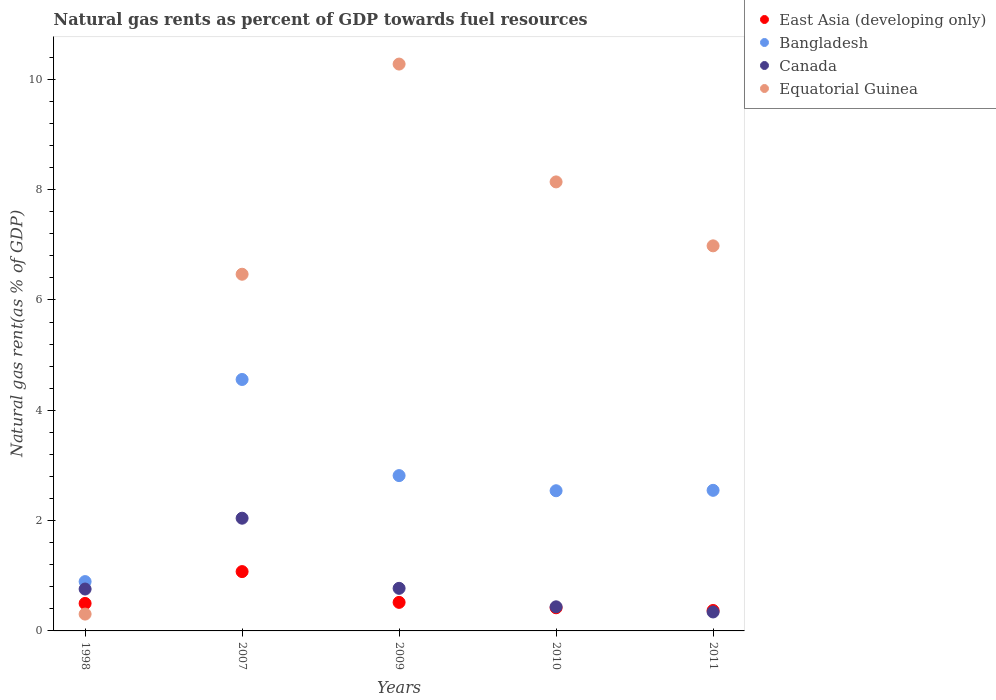How many different coloured dotlines are there?
Your response must be concise. 4. What is the natural gas rent in East Asia (developing only) in 2007?
Provide a succinct answer. 1.08. Across all years, what is the maximum natural gas rent in East Asia (developing only)?
Provide a succinct answer. 1.08. Across all years, what is the minimum natural gas rent in East Asia (developing only)?
Offer a terse response. 0.37. In which year was the natural gas rent in Bangladesh minimum?
Your answer should be very brief. 1998. What is the total natural gas rent in Canada in the graph?
Your answer should be compact. 4.36. What is the difference between the natural gas rent in Canada in 2007 and that in 2010?
Your response must be concise. 1.61. What is the difference between the natural gas rent in East Asia (developing only) in 1998 and the natural gas rent in Bangladesh in 2010?
Offer a very short reply. -2.04. What is the average natural gas rent in Equatorial Guinea per year?
Your answer should be compact. 6.43. In the year 1998, what is the difference between the natural gas rent in Canada and natural gas rent in East Asia (developing only)?
Give a very brief answer. 0.26. In how many years, is the natural gas rent in East Asia (developing only) greater than 0.4 %?
Provide a succinct answer. 4. What is the ratio of the natural gas rent in East Asia (developing only) in 1998 to that in 2009?
Your answer should be very brief. 0.96. Is the natural gas rent in Canada in 2009 less than that in 2010?
Your answer should be very brief. No. What is the difference between the highest and the second highest natural gas rent in East Asia (developing only)?
Offer a very short reply. 0.56. What is the difference between the highest and the lowest natural gas rent in Bangladesh?
Your answer should be compact. 3.66. Does the natural gas rent in Canada monotonically increase over the years?
Your response must be concise. No. Is the natural gas rent in Canada strictly less than the natural gas rent in East Asia (developing only) over the years?
Your answer should be compact. No. How many dotlines are there?
Your answer should be very brief. 4. How many years are there in the graph?
Offer a very short reply. 5. Where does the legend appear in the graph?
Your answer should be compact. Top right. How are the legend labels stacked?
Provide a short and direct response. Vertical. What is the title of the graph?
Ensure brevity in your answer.  Natural gas rents as percent of GDP towards fuel resources. Does "Romania" appear as one of the legend labels in the graph?
Your answer should be compact. No. What is the label or title of the X-axis?
Your answer should be very brief. Years. What is the label or title of the Y-axis?
Ensure brevity in your answer.  Natural gas rent(as % of GDP). What is the Natural gas rent(as % of GDP) in East Asia (developing only) in 1998?
Make the answer very short. 0.5. What is the Natural gas rent(as % of GDP) in Bangladesh in 1998?
Your answer should be very brief. 0.89. What is the Natural gas rent(as % of GDP) of Canada in 1998?
Provide a succinct answer. 0.76. What is the Natural gas rent(as % of GDP) of Equatorial Guinea in 1998?
Your response must be concise. 0.31. What is the Natural gas rent(as % of GDP) of East Asia (developing only) in 2007?
Give a very brief answer. 1.08. What is the Natural gas rent(as % of GDP) of Bangladesh in 2007?
Offer a terse response. 4.56. What is the Natural gas rent(as % of GDP) in Canada in 2007?
Your response must be concise. 2.04. What is the Natural gas rent(as % of GDP) in Equatorial Guinea in 2007?
Offer a terse response. 6.47. What is the Natural gas rent(as % of GDP) in East Asia (developing only) in 2009?
Offer a very short reply. 0.52. What is the Natural gas rent(as % of GDP) in Bangladesh in 2009?
Provide a short and direct response. 2.82. What is the Natural gas rent(as % of GDP) in Canada in 2009?
Offer a terse response. 0.77. What is the Natural gas rent(as % of GDP) of Equatorial Guinea in 2009?
Your answer should be compact. 10.28. What is the Natural gas rent(as % of GDP) in East Asia (developing only) in 2010?
Keep it short and to the point. 0.42. What is the Natural gas rent(as % of GDP) of Bangladesh in 2010?
Your response must be concise. 2.54. What is the Natural gas rent(as % of GDP) in Canada in 2010?
Your answer should be very brief. 0.44. What is the Natural gas rent(as % of GDP) of Equatorial Guinea in 2010?
Make the answer very short. 8.14. What is the Natural gas rent(as % of GDP) in East Asia (developing only) in 2011?
Make the answer very short. 0.37. What is the Natural gas rent(as % of GDP) of Bangladesh in 2011?
Your response must be concise. 2.55. What is the Natural gas rent(as % of GDP) of Canada in 2011?
Give a very brief answer. 0.34. What is the Natural gas rent(as % of GDP) of Equatorial Guinea in 2011?
Provide a short and direct response. 6.98. Across all years, what is the maximum Natural gas rent(as % of GDP) of East Asia (developing only)?
Give a very brief answer. 1.08. Across all years, what is the maximum Natural gas rent(as % of GDP) of Bangladesh?
Provide a short and direct response. 4.56. Across all years, what is the maximum Natural gas rent(as % of GDP) in Canada?
Ensure brevity in your answer.  2.04. Across all years, what is the maximum Natural gas rent(as % of GDP) in Equatorial Guinea?
Provide a short and direct response. 10.28. Across all years, what is the minimum Natural gas rent(as % of GDP) in East Asia (developing only)?
Provide a succinct answer. 0.37. Across all years, what is the minimum Natural gas rent(as % of GDP) in Bangladesh?
Keep it short and to the point. 0.89. Across all years, what is the minimum Natural gas rent(as % of GDP) in Canada?
Offer a terse response. 0.34. Across all years, what is the minimum Natural gas rent(as % of GDP) of Equatorial Guinea?
Your answer should be very brief. 0.31. What is the total Natural gas rent(as % of GDP) of East Asia (developing only) in the graph?
Give a very brief answer. 2.88. What is the total Natural gas rent(as % of GDP) in Bangladesh in the graph?
Offer a very short reply. 13.36. What is the total Natural gas rent(as % of GDP) in Canada in the graph?
Your answer should be compact. 4.36. What is the total Natural gas rent(as % of GDP) in Equatorial Guinea in the graph?
Provide a succinct answer. 32.17. What is the difference between the Natural gas rent(as % of GDP) in East Asia (developing only) in 1998 and that in 2007?
Ensure brevity in your answer.  -0.58. What is the difference between the Natural gas rent(as % of GDP) in Bangladesh in 1998 and that in 2007?
Your answer should be very brief. -3.66. What is the difference between the Natural gas rent(as % of GDP) of Canada in 1998 and that in 2007?
Provide a short and direct response. -1.28. What is the difference between the Natural gas rent(as % of GDP) of Equatorial Guinea in 1998 and that in 2007?
Provide a succinct answer. -6.16. What is the difference between the Natural gas rent(as % of GDP) of East Asia (developing only) in 1998 and that in 2009?
Make the answer very short. -0.02. What is the difference between the Natural gas rent(as % of GDP) in Bangladesh in 1998 and that in 2009?
Your answer should be compact. -1.92. What is the difference between the Natural gas rent(as % of GDP) in Canada in 1998 and that in 2009?
Provide a short and direct response. -0.01. What is the difference between the Natural gas rent(as % of GDP) in Equatorial Guinea in 1998 and that in 2009?
Offer a very short reply. -9.97. What is the difference between the Natural gas rent(as % of GDP) of East Asia (developing only) in 1998 and that in 2010?
Your answer should be compact. 0.08. What is the difference between the Natural gas rent(as % of GDP) in Bangladesh in 1998 and that in 2010?
Your response must be concise. -1.65. What is the difference between the Natural gas rent(as % of GDP) in Canada in 1998 and that in 2010?
Your answer should be compact. 0.32. What is the difference between the Natural gas rent(as % of GDP) in Equatorial Guinea in 1998 and that in 2010?
Your answer should be very brief. -7.84. What is the difference between the Natural gas rent(as % of GDP) in East Asia (developing only) in 1998 and that in 2011?
Offer a very short reply. 0.13. What is the difference between the Natural gas rent(as % of GDP) of Bangladesh in 1998 and that in 2011?
Your response must be concise. -1.65. What is the difference between the Natural gas rent(as % of GDP) of Canada in 1998 and that in 2011?
Give a very brief answer. 0.42. What is the difference between the Natural gas rent(as % of GDP) of Equatorial Guinea in 1998 and that in 2011?
Keep it short and to the point. -6.68. What is the difference between the Natural gas rent(as % of GDP) of East Asia (developing only) in 2007 and that in 2009?
Keep it short and to the point. 0.56. What is the difference between the Natural gas rent(as % of GDP) of Bangladesh in 2007 and that in 2009?
Provide a succinct answer. 1.74. What is the difference between the Natural gas rent(as % of GDP) in Canada in 2007 and that in 2009?
Make the answer very short. 1.27. What is the difference between the Natural gas rent(as % of GDP) of Equatorial Guinea in 2007 and that in 2009?
Provide a succinct answer. -3.81. What is the difference between the Natural gas rent(as % of GDP) in East Asia (developing only) in 2007 and that in 2010?
Offer a very short reply. 0.66. What is the difference between the Natural gas rent(as % of GDP) in Bangladesh in 2007 and that in 2010?
Your response must be concise. 2.02. What is the difference between the Natural gas rent(as % of GDP) of Canada in 2007 and that in 2010?
Provide a succinct answer. 1.61. What is the difference between the Natural gas rent(as % of GDP) of Equatorial Guinea in 2007 and that in 2010?
Provide a short and direct response. -1.67. What is the difference between the Natural gas rent(as % of GDP) of East Asia (developing only) in 2007 and that in 2011?
Make the answer very short. 0.71. What is the difference between the Natural gas rent(as % of GDP) of Bangladesh in 2007 and that in 2011?
Offer a terse response. 2.01. What is the difference between the Natural gas rent(as % of GDP) of Canada in 2007 and that in 2011?
Your answer should be very brief. 1.7. What is the difference between the Natural gas rent(as % of GDP) of Equatorial Guinea in 2007 and that in 2011?
Keep it short and to the point. -0.51. What is the difference between the Natural gas rent(as % of GDP) in East Asia (developing only) in 2009 and that in 2010?
Offer a very short reply. 0.1. What is the difference between the Natural gas rent(as % of GDP) in Bangladesh in 2009 and that in 2010?
Make the answer very short. 0.27. What is the difference between the Natural gas rent(as % of GDP) in Canada in 2009 and that in 2010?
Give a very brief answer. 0.34. What is the difference between the Natural gas rent(as % of GDP) of Equatorial Guinea in 2009 and that in 2010?
Make the answer very short. 2.14. What is the difference between the Natural gas rent(as % of GDP) of East Asia (developing only) in 2009 and that in 2011?
Keep it short and to the point. 0.15. What is the difference between the Natural gas rent(as % of GDP) of Bangladesh in 2009 and that in 2011?
Provide a short and direct response. 0.27. What is the difference between the Natural gas rent(as % of GDP) in Canada in 2009 and that in 2011?
Offer a terse response. 0.43. What is the difference between the Natural gas rent(as % of GDP) in Equatorial Guinea in 2009 and that in 2011?
Offer a very short reply. 3.3. What is the difference between the Natural gas rent(as % of GDP) of East Asia (developing only) in 2010 and that in 2011?
Your answer should be very brief. 0.05. What is the difference between the Natural gas rent(as % of GDP) in Bangladesh in 2010 and that in 2011?
Ensure brevity in your answer.  -0.01. What is the difference between the Natural gas rent(as % of GDP) in Canada in 2010 and that in 2011?
Your answer should be compact. 0.09. What is the difference between the Natural gas rent(as % of GDP) of Equatorial Guinea in 2010 and that in 2011?
Your answer should be very brief. 1.16. What is the difference between the Natural gas rent(as % of GDP) of East Asia (developing only) in 1998 and the Natural gas rent(as % of GDP) of Bangladesh in 2007?
Offer a very short reply. -4.06. What is the difference between the Natural gas rent(as % of GDP) in East Asia (developing only) in 1998 and the Natural gas rent(as % of GDP) in Canada in 2007?
Give a very brief answer. -1.54. What is the difference between the Natural gas rent(as % of GDP) in East Asia (developing only) in 1998 and the Natural gas rent(as % of GDP) in Equatorial Guinea in 2007?
Offer a terse response. -5.97. What is the difference between the Natural gas rent(as % of GDP) in Bangladesh in 1998 and the Natural gas rent(as % of GDP) in Canada in 2007?
Your answer should be very brief. -1.15. What is the difference between the Natural gas rent(as % of GDP) in Bangladesh in 1998 and the Natural gas rent(as % of GDP) in Equatorial Guinea in 2007?
Offer a terse response. -5.57. What is the difference between the Natural gas rent(as % of GDP) in Canada in 1998 and the Natural gas rent(as % of GDP) in Equatorial Guinea in 2007?
Provide a short and direct response. -5.71. What is the difference between the Natural gas rent(as % of GDP) of East Asia (developing only) in 1998 and the Natural gas rent(as % of GDP) of Bangladesh in 2009?
Keep it short and to the point. -2.32. What is the difference between the Natural gas rent(as % of GDP) of East Asia (developing only) in 1998 and the Natural gas rent(as % of GDP) of Canada in 2009?
Make the answer very short. -0.27. What is the difference between the Natural gas rent(as % of GDP) of East Asia (developing only) in 1998 and the Natural gas rent(as % of GDP) of Equatorial Guinea in 2009?
Offer a terse response. -9.78. What is the difference between the Natural gas rent(as % of GDP) in Bangladesh in 1998 and the Natural gas rent(as % of GDP) in Canada in 2009?
Provide a short and direct response. 0.12. What is the difference between the Natural gas rent(as % of GDP) in Bangladesh in 1998 and the Natural gas rent(as % of GDP) in Equatorial Guinea in 2009?
Your response must be concise. -9.38. What is the difference between the Natural gas rent(as % of GDP) of Canada in 1998 and the Natural gas rent(as % of GDP) of Equatorial Guinea in 2009?
Offer a terse response. -9.52. What is the difference between the Natural gas rent(as % of GDP) of East Asia (developing only) in 1998 and the Natural gas rent(as % of GDP) of Bangladesh in 2010?
Provide a succinct answer. -2.04. What is the difference between the Natural gas rent(as % of GDP) in East Asia (developing only) in 1998 and the Natural gas rent(as % of GDP) in Canada in 2010?
Provide a succinct answer. 0.06. What is the difference between the Natural gas rent(as % of GDP) of East Asia (developing only) in 1998 and the Natural gas rent(as % of GDP) of Equatorial Guinea in 2010?
Ensure brevity in your answer.  -7.64. What is the difference between the Natural gas rent(as % of GDP) of Bangladesh in 1998 and the Natural gas rent(as % of GDP) of Canada in 2010?
Provide a succinct answer. 0.46. What is the difference between the Natural gas rent(as % of GDP) in Bangladesh in 1998 and the Natural gas rent(as % of GDP) in Equatorial Guinea in 2010?
Keep it short and to the point. -7.25. What is the difference between the Natural gas rent(as % of GDP) of Canada in 1998 and the Natural gas rent(as % of GDP) of Equatorial Guinea in 2010?
Your answer should be very brief. -7.38. What is the difference between the Natural gas rent(as % of GDP) of East Asia (developing only) in 1998 and the Natural gas rent(as % of GDP) of Bangladesh in 2011?
Make the answer very short. -2.05. What is the difference between the Natural gas rent(as % of GDP) in East Asia (developing only) in 1998 and the Natural gas rent(as % of GDP) in Canada in 2011?
Keep it short and to the point. 0.15. What is the difference between the Natural gas rent(as % of GDP) in East Asia (developing only) in 1998 and the Natural gas rent(as % of GDP) in Equatorial Guinea in 2011?
Provide a short and direct response. -6.48. What is the difference between the Natural gas rent(as % of GDP) of Bangladesh in 1998 and the Natural gas rent(as % of GDP) of Canada in 2011?
Your answer should be very brief. 0.55. What is the difference between the Natural gas rent(as % of GDP) of Bangladesh in 1998 and the Natural gas rent(as % of GDP) of Equatorial Guinea in 2011?
Provide a short and direct response. -6.09. What is the difference between the Natural gas rent(as % of GDP) of Canada in 1998 and the Natural gas rent(as % of GDP) of Equatorial Guinea in 2011?
Your answer should be very brief. -6.22. What is the difference between the Natural gas rent(as % of GDP) of East Asia (developing only) in 2007 and the Natural gas rent(as % of GDP) of Bangladesh in 2009?
Your answer should be very brief. -1.74. What is the difference between the Natural gas rent(as % of GDP) in East Asia (developing only) in 2007 and the Natural gas rent(as % of GDP) in Canada in 2009?
Your answer should be compact. 0.3. What is the difference between the Natural gas rent(as % of GDP) of East Asia (developing only) in 2007 and the Natural gas rent(as % of GDP) of Equatorial Guinea in 2009?
Make the answer very short. -9.2. What is the difference between the Natural gas rent(as % of GDP) in Bangladesh in 2007 and the Natural gas rent(as % of GDP) in Canada in 2009?
Offer a terse response. 3.79. What is the difference between the Natural gas rent(as % of GDP) in Bangladesh in 2007 and the Natural gas rent(as % of GDP) in Equatorial Guinea in 2009?
Provide a succinct answer. -5.72. What is the difference between the Natural gas rent(as % of GDP) of Canada in 2007 and the Natural gas rent(as % of GDP) of Equatorial Guinea in 2009?
Offer a terse response. -8.23. What is the difference between the Natural gas rent(as % of GDP) of East Asia (developing only) in 2007 and the Natural gas rent(as % of GDP) of Bangladesh in 2010?
Your answer should be very brief. -1.47. What is the difference between the Natural gas rent(as % of GDP) in East Asia (developing only) in 2007 and the Natural gas rent(as % of GDP) in Canada in 2010?
Your answer should be very brief. 0.64. What is the difference between the Natural gas rent(as % of GDP) of East Asia (developing only) in 2007 and the Natural gas rent(as % of GDP) of Equatorial Guinea in 2010?
Provide a short and direct response. -7.07. What is the difference between the Natural gas rent(as % of GDP) of Bangladesh in 2007 and the Natural gas rent(as % of GDP) of Canada in 2010?
Provide a short and direct response. 4.12. What is the difference between the Natural gas rent(as % of GDP) of Bangladesh in 2007 and the Natural gas rent(as % of GDP) of Equatorial Guinea in 2010?
Your response must be concise. -3.58. What is the difference between the Natural gas rent(as % of GDP) of Canada in 2007 and the Natural gas rent(as % of GDP) of Equatorial Guinea in 2010?
Your answer should be compact. -6.1. What is the difference between the Natural gas rent(as % of GDP) in East Asia (developing only) in 2007 and the Natural gas rent(as % of GDP) in Bangladesh in 2011?
Provide a succinct answer. -1.47. What is the difference between the Natural gas rent(as % of GDP) in East Asia (developing only) in 2007 and the Natural gas rent(as % of GDP) in Canada in 2011?
Make the answer very short. 0.73. What is the difference between the Natural gas rent(as % of GDP) in East Asia (developing only) in 2007 and the Natural gas rent(as % of GDP) in Equatorial Guinea in 2011?
Offer a terse response. -5.91. What is the difference between the Natural gas rent(as % of GDP) in Bangladesh in 2007 and the Natural gas rent(as % of GDP) in Canada in 2011?
Your answer should be compact. 4.21. What is the difference between the Natural gas rent(as % of GDP) of Bangladesh in 2007 and the Natural gas rent(as % of GDP) of Equatorial Guinea in 2011?
Ensure brevity in your answer.  -2.42. What is the difference between the Natural gas rent(as % of GDP) of Canada in 2007 and the Natural gas rent(as % of GDP) of Equatorial Guinea in 2011?
Keep it short and to the point. -4.94. What is the difference between the Natural gas rent(as % of GDP) of East Asia (developing only) in 2009 and the Natural gas rent(as % of GDP) of Bangladesh in 2010?
Make the answer very short. -2.02. What is the difference between the Natural gas rent(as % of GDP) in East Asia (developing only) in 2009 and the Natural gas rent(as % of GDP) in Canada in 2010?
Make the answer very short. 0.08. What is the difference between the Natural gas rent(as % of GDP) in East Asia (developing only) in 2009 and the Natural gas rent(as % of GDP) in Equatorial Guinea in 2010?
Your response must be concise. -7.62. What is the difference between the Natural gas rent(as % of GDP) in Bangladesh in 2009 and the Natural gas rent(as % of GDP) in Canada in 2010?
Provide a succinct answer. 2.38. What is the difference between the Natural gas rent(as % of GDP) of Bangladesh in 2009 and the Natural gas rent(as % of GDP) of Equatorial Guinea in 2010?
Your response must be concise. -5.32. What is the difference between the Natural gas rent(as % of GDP) of Canada in 2009 and the Natural gas rent(as % of GDP) of Equatorial Guinea in 2010?
Your response must be concise. -7.37. What is the difference between the Natural gas rent(as % of GDP) in East Asia (developing only) in 2009 and the Natural gas rent(as % of GDP) in Bangladesh in 2011?
Give a very brief answer. -2.03. What is the difference between the Natural gas rent(as % of GDP) of East Asia (developing only) in 2009 and the Natural gas rent(as % of GDP) of Canada in 2011?
Offer a terse response. 0.17. What is the difference between the Natural gas rent(as % of GDP) in East Asia (developing only) in 2009 and the Natural gas rent(as % of GDP) in Equatorial Guinea in 2011?
Your answer should be compact. -6.46. What is the difference between the Natural gas rent(as % of GDP) of Bangladesh in 2009 and the Natural gas rent(as % of GDP) of Canada in 2011?
Your response must be concise. 2.47. What is the difference between the Natural gas rent(as % of GDP) of Bangladesh in 2009 and the Natural gas rent(as % of GDP) of Equatorial Guinea in 2011?
Your response must be concise. -4.17. What is the difference between the Natural gas rent(as % of GDP) of Canada in 2009 and the Natural gas rent(as % of GDP) of Equatorial Guinea in 2011?
Provide a short and direct response. -6.21. What is the difference between the Natural gas rent(as % of GDP) in East Asia (developing only) in 2010 and the Natural gas rent(as % of GDP) in Bangladesh in 2011?
Keep it short and to the point. -2.13. What is the difference between the Natural gas rent(as % of GDP) of East Asia (developing only) in 2010 and the Natural gas rent(as % of GDP) of Canada in 2011?
Ensure brevity in your answer.  0.08. What is the difference between the Natural gas rent(as % of GDP) of East Asia (developing only) in 2010 and the Natural gas rent(as % of GDP) of Equatorial Guinea in 2011?
Your answer should be very brief. -6.56. What is the difference between the Natural gas rent(as % of GDP) in Bangladesh in 2010 and the Natural gas rent(as % of GDP) in Canada in 2011?
Your response must be concise. 2.2. What is the difference between the Natural gas rent(as % of GDP) in Bangladesh in 2010 and the Natural gas rent(as % of GDP) in Equatorial Guinea in 2011?
Your answer should be very brief. -4.44. What is the difference between the Natural gas rent(as % of GDP) in Canada in 2010 and the Natural gas rent(as % of GDP) in Equatorial Guinea in 2011?
Ensure brevity in your answer.  -6.54. What is the average Natural gas rent(as % of GDP) in East Asia (developing only) per year?
Offer a very short reply. 0.58. What is the average Natural gas rent(as % of GDP) of Bangladesh per year?
Offer a very short reply. 2.67. What is the average Natural gas rent(as % of GDP) in Canada per year?
Offer a terse response. 0.87. What is the average Natural gas rent(as % of GDP) in Equatorial Guinea per year?
Your answer should be very brief. 6.43. In the year 1998, what is the difference between the Natural gas rent(as % of GDP) in East Asia (developing only) and Natural gas rent(as % of GDP) in Bangladesh?
Your response must be concise. -0.4. In the year 1998, what is the difference between the Natural gas rent(as % of GDP) of East Asia (developing only) and Natural gas rent(as % of GDP) of Canada?
Provide a short and direct response. -0.26. In the year 1998, what is the difference between the Natural gas rent(as % of GDP) in East Asia (developing only) and Natural gas rent(as % of GDP) in Equatorial Guinea?
Keep it short and to the point. 0.19. In the year 1998, what is the difference between the Natural gas rent(as % of GDP) in Bangladesh and Natural gas rent(as % of GDP) in Canada?
Provide a succinct answer. 0.13. In the year 1998, what is the difference between the Natural gas rent(as % of GDP) in Bangladesh and Natural gas rent(as % of GDP) in Equatorial Guinea?
Offer a very short reply. 0.59. In the year 1998, what is the difference between the Natural gas rent(as % of GDP) of Canada and Natural gas rent(as % of GDP) of Equatorial Guinea?
Offer a very short reply. 0.45. In the year 2007, what is the difference between the Natural gas rent(as % of GDP) of East Asia (developing only) and Natural gas rent(as % of GDP) of Bangladesh?
Your answer should be compact. -3.48. In the year 2007, what is the difference between the Natural gas rent(as % of GDP) in East Asia (developing only) and Natural gas rent(as % of GDP) in Canada?
Offer a terse response. -0.97. In the year 2007, what is the difference between the Natural gas rent(as % of GDP) in East Asia (developing only) and Natural gas rent(as % of GDP) in Equatorial Guinea?
Make the answer very short. -5.39. In the year 2007, what is the difference between the Natural gas rent(as % of GDP) of Bangladesh and Natural gas rent(as % of GDP) of Canada?
Provide a short and direct response. 2.52. In the year 2007, what is the difference between the Natural gas rent(as % of GDP) in Bangladesh and Natural gas rent(as % of GDP) in Equatorial Guinea?
Offer a very short reply. -1.91. In the year 2007, what is the difference between the Natural gas rent(as % of GDP) in Canada and Natural gas rent(as % of GDP) in Equatorial Guinea?
Offer a terse response. -4.42. In the year 2009, what is the difference between the Natural gas rent(as % of GDP) of East Asia (developing only) and Natural gas rent(as % of GDP) of Bangladesh?
Offer a terse response. -2.3. In the year 2009, what is the difference between the Natural gas rent(as % of GDP) in East Asia (developing only) and Natural gas rent(as % of GDP) in Canada?
Provide a short and direct response. -0.25. In the year 2009, what is the difference between the Natural gas rent(as % of GDP) in East Asia (developing only) and Natural gas rent(as % of GDP) in Equatorial Guinea?
Your response must be concise. -9.76. In the year 2009, what is the difference between the Natural gas rent(as % of GDP) in Bangladesh and Natural gas rent(as % of GDP) in Canada?
Provide a succinct answer. 2.04. In the year 2009, what is the difference between the Natural gas rent(as % of GDP) in Bangladesh and Natural gas rent(as % of GDP) in Equatorial Guinea?
Your response must be concise. -7.46. In the year 2009, what is the difference between the Natural gas rent(as % of GDP) in Canada and Natural gas rent(as % of GDP) in Equatorial Guinea?
Offer a very short reply. -9.5. In the year 2010, what is the difference between the Natural gas rent(as % of GDP) in East Asia (developing only) and Natural gas rent(as % of GDP) in Bangladesh?
Keep it short and to the point. -2.12. In the year 2010, what is the difference between the Natural gas rent(as % of GDP) of East Asia (developing only) and Natural gas rent(as % of GDP) of Canada?
Offer a terse response. -0.02. In the year 2010, what is the difference between the Natural gas rent(as % of GDP) in East Asia (developing only) and Natural gas rent(as % of GDP) in Equatorial Guinea?
Offer a very short reply. -7.72. In the year 2010, what is the difference between the Natural gas rent(as % of GDP) in Bangladesh and Natural gas rent(as % of GDP) in Canada?
Make the answer very short. 2.1. In the year 2010, what is the difference between the Natural gas rent(as % of GDP) of Bangladesh and Natural gas rent(as % of GDP) of Equatorial Guinea?
Provide a succinct answer. -5.6. In the year 2010, what is the difference between the Natural gas rent(as % of GDP) of Canada and Natural gas rent(as % of GDP) of Equatorial Guinea?
Offer a terse response. -7.7. In the year 2011, what is the difference between the Natural gas rent(as % of GDP) in East Asia (developing only) and Natural gas rent(as % of GDP) in Bangladesh?
Give a very brief answer. -2.18. In the year 2011, what is the difference between the Natural gas rent(as % of GDP) of East Asia (developing only) and Natural gas rent(as % of GDP) of Canada?
Your answer should be compact. 0.03. In the year 2011, what is the difference between the Natural gas rent(as % of GDP) of East Asia (developing only) and Natural gas rent(as % of GDP) of Equatorial Guinea?
Provide a short and direct response. -6.61. In the year 2011, what is the difference between the Natural gas rent(as % of GDP) in Bangladesh and Natural gas rent(as % of GDP) in Canada?
Your answer should be compact. 2.21. In the year 2011, what is the difference between the Natural gas rent(as % of GDP) of Bangladesh and Natural gas rent(as % of GDP) of Equatorial Guinea?
Your answer should be compact. -4.43. In the year 2011, what is the difference between the Natural gas rent(as % of GDP) of Canada and Natural gas rent(as % of GDP) of Equatorial Guinea?
Keep it short and to the point. -6.64. What is the ratio of the Natural gas rent(as % of GDP) in East Asia (developing only) in 1998 to that in 2007?
Your answer should be compact. 0.46. What is the ratio of the Natural gas rent(as % of GDP) in Bangladesh in 1998 to that in 2007?
Make the answer very short. 0.2. What is the ratio of the Natural gas rent(as % of GDP) of Canada in 1998 to that in 2007?
Offer a very short reply. 0.37. What is the ratio of the Natural gas rent(as % of GDP) of Equatorial Guinea in 1998 to that in 2007?
Provide a succinct answer. 0.05. What is the ratio of the Natural gas rent(as % of GDP) of East Asia (developing only) in 1998 to that in 2009?
Your answer should be compact. 0.96. What is the ratio of the Natural gas rent(as % of GDP) in Bangladesh in 1998 to that in 2009?
Give a very brief answer. 0.32. What is the ratio of the Natural gas rent(as % of GDP) of Canada in 1998 to that in 2009?
Provide a short and direct response. 0.98. What is the ratio of the Natural gas rent(as % of GDP) of Equatorial Guinea in 1998 to that in 2009?
Give a very brief answer. 0.03. What is the ratio of the Natural gas rent(as % of GDP) in East Asia (developing only) in 1998 to that in 2010?
Provide a short and direct response. 1.19. What is the ratio of the Natural gas rent(as % of GDP) of Bangladesh in 1998 to that in 2010?
Offer a very short reply. 0.35. What is the ratio of the Natural gas rent(as % of GDP) in Canada in 1998 to that in 2010?
Your answer should be compact. 1.74. What is the ratio of the Natural gas rent(as % of GDP) in Equatorial Guinea in 1998 to that in 2010?
Provide a succinct answer. 0.04. What is the ratio of the Natural gas rent(as % of GDP) of East Asia (developing only) in 1998 to that in 2011?
Your answer should be very brief. 1.35. What is the ratio of the Natural gas rent(as % of GDP) in Bangladesh in 1998 to that in 2011?
Offer a very short reply. 0.35. What is the ratio of the Natural gas rent(as % of GDP) in Canada in 1998 to that in 2011?
Make the answer very short. 2.21. What is the ratio of the Natural gas rent(as % of GDP) of Equatorial Guinea in 1998 to that in 2011?
Ensure brevity in your answer.  0.04. What is the ratio of the Natural gas rent(as % of GDP) in East Asia (developing only) in 2007 to that in 2009?
Provide a succinct answer. 2.08. What is the ratio of the Natural gas rent(as % of GDP) in Bangladesh in 2007 to that in 2009?
Your answer should be very brief. 1.62. What is the ratio of the Natural gas rent(as % of GDP) of Canada in 2007 to that in 2009?
Offer a very short reply. 2.65. What is the ratio of the Natural gas rent(as % of GDP) in Equatorial Guinea in 2007 to that in 2009?
Your response must be concise. 0.63. What is the ratio of the Natural gas rent(as % of GDP) of East Asia (developing only) in 2007 to that in 2010?
Provide a short and direct response. 2.56. What is the ratio of the Natural gas rent(as % of GDP) in Bangladesh in 2007 to that in 2010?
Provide a succinct answer. 1.79. What is the ratio of the Natural gas rent(as % of GDP) of Canada in 2007 to that in 2010?
Your answer should be very brief. 4.68. What is the ratio of the Natural gas rent(as % of GDP) of Equatorial Guinea in 2007 to that in 2010?
Offer a terse response. 0.79. What is the ratio of the Natural gas rent(as % of GDP) of East Asia (developing only) in 2007 to that in 2011?
Ensure brevity in your answer.  2.9. What is the ratio of the Natural gas rent(as % of GDP) of Bangladesh in 2007 to that in 2011?
Provide a short and direct response. 1.79. What is the ratio of the Natural gas rent(as % of GDP) in Canada in 2007 to that in 2011?
Your response must be concise. 5.94. What is the ratio of the Natural gas rent(as % of GDP) in Equatorial Guinea in 2007 to that in 2011?
Offer a terse response. 0.93. What is the ratio of the Natural gas rent(as % of GDP) in East Asia (developing only) in 2009 to that in 2010?
Provide a succinct answer. 1.23. What is the ratio of the Natural gas rent(as % of GDP) of Bangladesh in 2009 to that in 2010?
Make the answer very short. 1.11. What is the ratio of the Natural gas rent(as % of GDP) in Canada in 2009 to that in 2010?
Provide a succinct answer. 1.77. What is the ratio of the Natural gas rent(as % of GDP) in Equatorial Guinea in 2009 to that in 2010?
Your answer should be compact. 1.26. What is the ratio of the Natural gas rent(as % of GDP) of East Asia (developing only) in 2009 to that in 2011?
Make the answer very short. 1.4. What is the ratio of the Natural gas rent(as % of GDP) in Bangladesh in 2009 to that in 2011?
Give a very brief answer. 1.1. What is the ratio of the Natural gas rent(as % of GDP) of Canada in 2009 to that in 2011?
Your response must be concise. 2.25. What is the ratio of the Natural gas rent(as % of GDP) in Equatorial Guinea in 2009 to that in 2011?
Your answer should be very brief. 1.47. What is the ratio of the Natural gas rent(as % of GDP) in East Asia (developing only) in 2010 to that in 2011?
Your answer should be very brief. 1.13. What is the ratio of the Natural gas rent(as % of GDP) in Canada in 2010 to that in 2011?
Give a very brief answer. 1.27. What is the ratio of the Natural gas rent(as % of GDP) of Equatorial Guinea in 2010 to that in 2011?
Offer a very short reply. 1.17. What is the difference between the highest and the second highest Natural gas rent(as % of GDP) in East Asia (developing only)?
Your response must be concise. 0.56. What is the difference between the highest and the second highest Natural gas rent(as % of GDP) of Bangladesh?
Your answer should be compact. 1.74. What is the difference between the highest and the second highest Natural gas rent(as % of GDP) of Canada?
Your response must be concise. 1.27. What is the difference between the highest and the second highest Natural gas rent(as % of GDP) of Equatorial Guinea?
Your answer should be very brief. 2.14. What is the difference between the highest and the lowest Natural gas rent(as % of GDP) of East Asia (developing only)?
Give a very brief answer. 0.71. What is the difference between the highest and the lowest Natural gas rent(as % of GDP) of Bangladesh?
Make the answer very short. 3.66. What is the difference between the highest and the lowest Natural gas rent(as % of GDP) in Canada?
Provide a succinct answer. 1.7. What is the difference between the highest and the lowest Natural gas rent(as % of GDP) in Equatorial Guinea?
Keep it short and to the point. 9.97. 